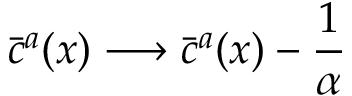<formula> <loc_0><loc_0><loc_500><loc_500>\bar { c } ^ { a } ( x ) \longrightarrow \bar { c } ^ { a } ( x ) - \frac { 1 } { \alpha }</formula> 